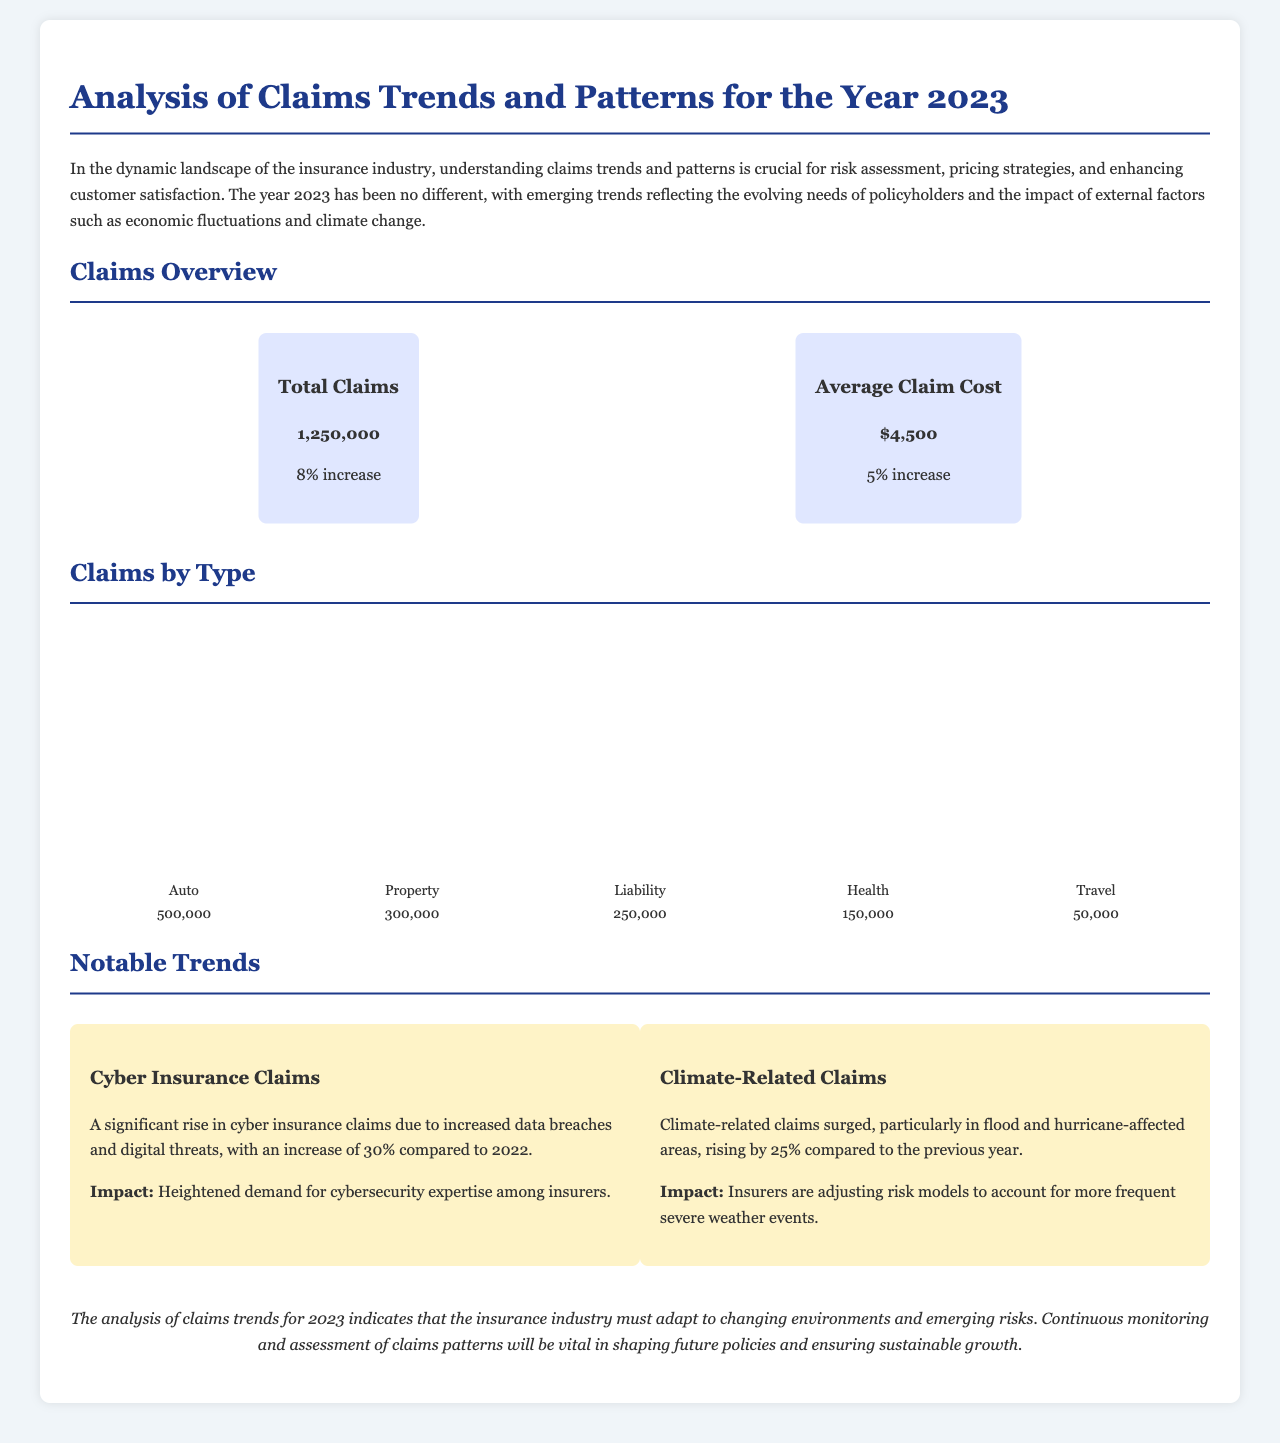What is the total number of claims in 2023? The total number of claims is presented directly as 1,250,000 in the overview section.
Answer: 1,250,000 What is the average claim cost in 2023? The average claim cost for the year is stated as $4,500 in the overview section.
Answer: $4,500 What percentage increase in total claims is reported? The report mentions an 8% increase in total claims compared to the previous year.
Answer: 8% Which type of claim has the highest frequency? The claims chart indicates that Auto claims are the most frequent at 500,000.
Answer: Auto What is the percentage increase in cyber insurance claims compared to 2022? The notable trends section states there is a 30% increase in cyber insurance claims from the previous year.
Answer: 30% How many property claims were filed in 2023? The claims chart specifies that there were 300,000 property claims during the year.
Answer: 300,000 What was the impact of climate-related claims? The document highlights that insurers are adjusting risk models due to climate-related claims, which surged by 25% compared to 2022.
Answer: Adjusting risk models How many travel claims were reported in 2023? The claims by type section indicates that there were 50,000 travel claims registered.
Answer: 50,000 What is a notable trend related to cyber insurance? One notable trend is the significant rise in cyber insurance claims, linked to increased data breaches.
Answer: Rise in cyber insurance claims 